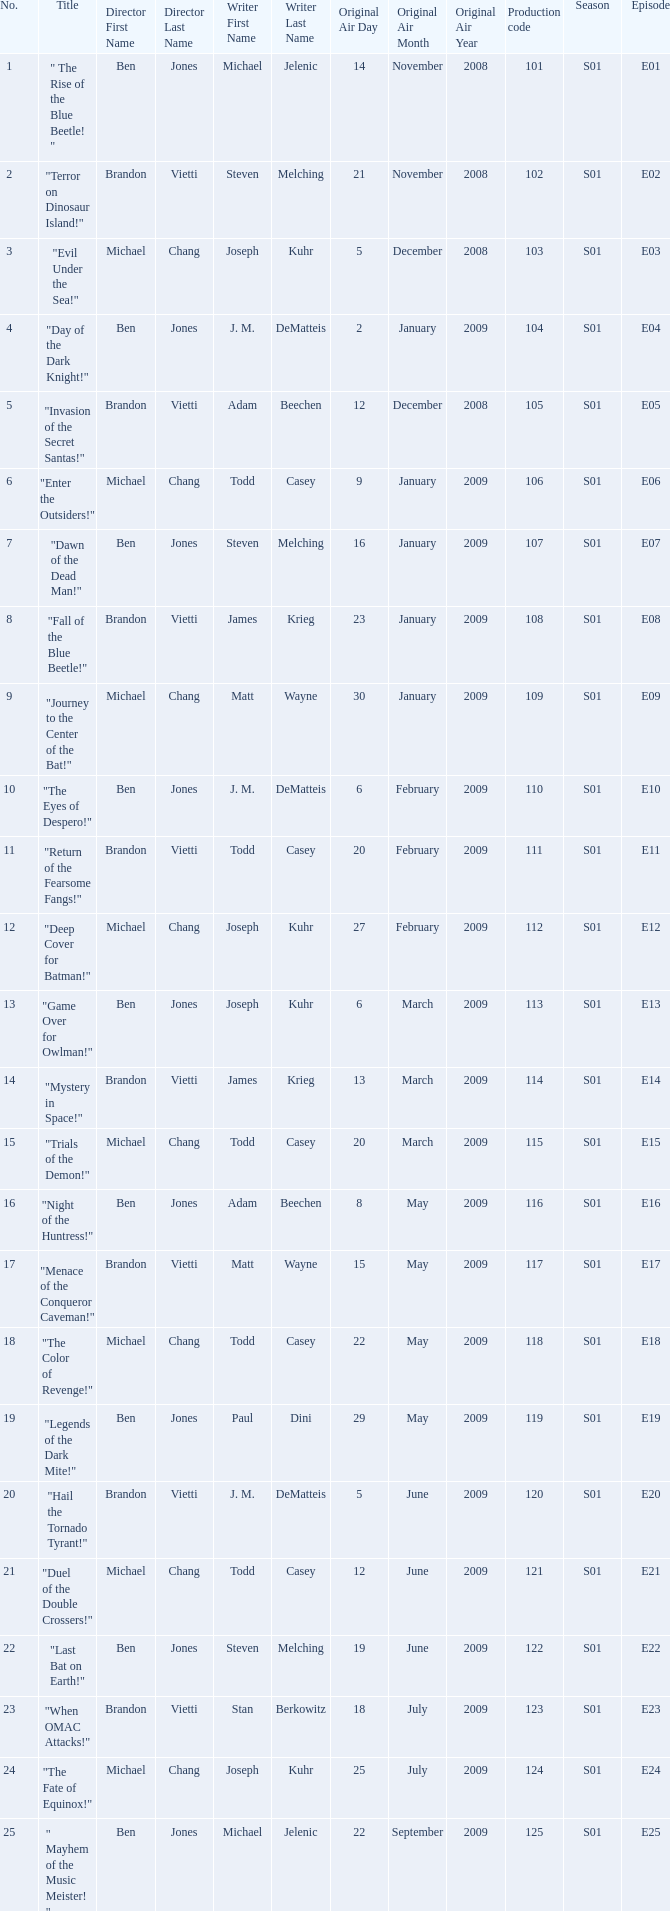Who directed s01e13 Ben Jones. 